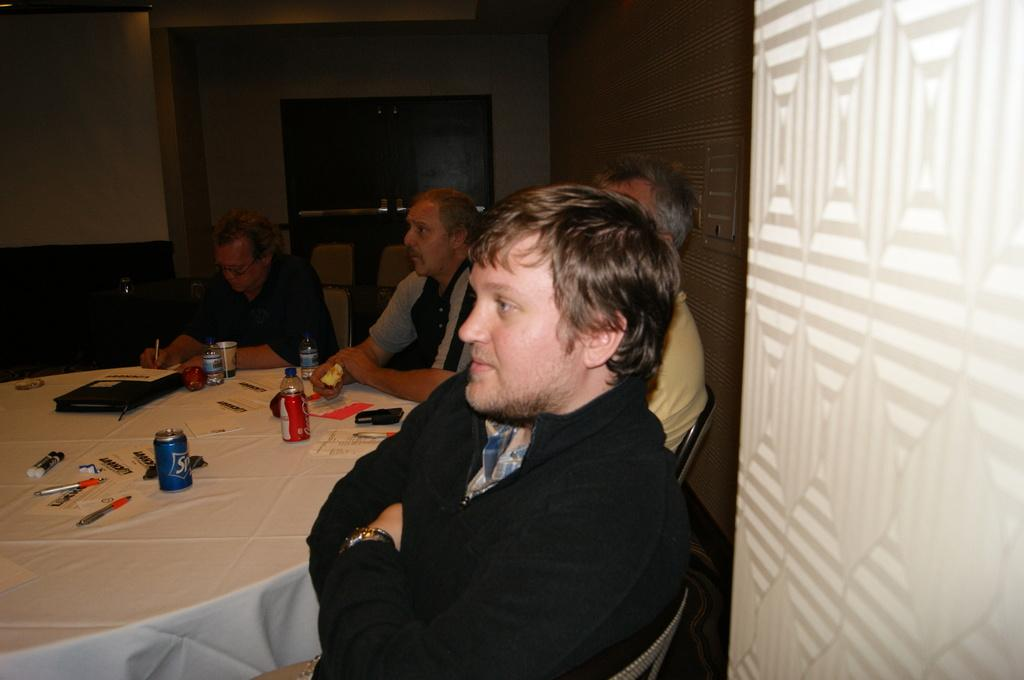What are the people in the image doing? The people in the image are sitting on chairs. What type of containers can be seen in the image? There are tins, bottles, and glasses in the image. What stationery items are present in the image? There are pens in the image. What type of writing material is present in the image? There are papers in the image. What is on the table in the image? There are objects on the table in the image. What is visible in the background of the image? There is a wall visible in the image. How many times do the people jump in the image? There is no jumping activity depicted in the image; the people are sitting on chairs. What type of badge is visible on the wall in the image? There is no badge present in the image; only a wall is visible in the background. 